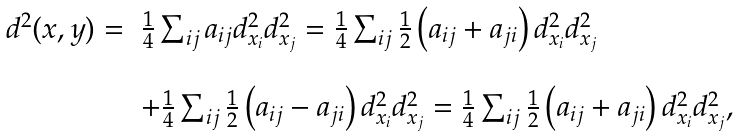Convert formula to latex. <formula><loc_0><loc_0><loc_500><loc_500>\begin{array} { l l } d ^ { 2 } ( x , y ) = & \frac { 1 } { 4 } \sum _ { i j } a _ { i j } d ^ { 2 } _ { x _ { i } } d ^ { 2 } _ { x _ { j } } = \frac { 1 } { 4 } \sum _ { i j } \frac { 1 } { 2 } \left ( a _ { i j } + a _ { j i } \right ) d ^ { 2 } _ { x _ { i } } d ^ { 2 } _ { x _ { j } } \\ \\ & + \frac { 1 } { 4 } \sum _ { i j } \frac { 1 } { 2 } \left ( a _ { i j } - a _ { j i } \right ) d ^ { 2 } _ { x _ { i } } d ^ { 2 } _ { x _ { j } } = \frac { 1 } { 4 } \sum _ { i j } \frac { 1 } { 2 } \left ( a _ { i j } + a _ { j i } \right ) d ^ { 2 } _ { x _ { i } } d ^ { 2 } _ { x _ { j } } , \end{array}</formula> 